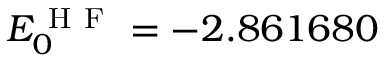Convert formula to latex. <formula><loc_0><loc_0><loc_500><loc_500>E _ { 0 } ^ { H F } = - 2 . 8 6 1 6 8 0</formula> 